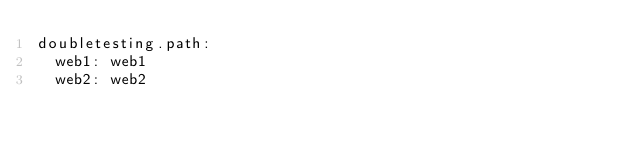Convert code to text. <code><loc_0><loc_0><loc_500><loc_500><_YAML_>doubletesting.path:
  web1: web1
  web2: web2</code> 